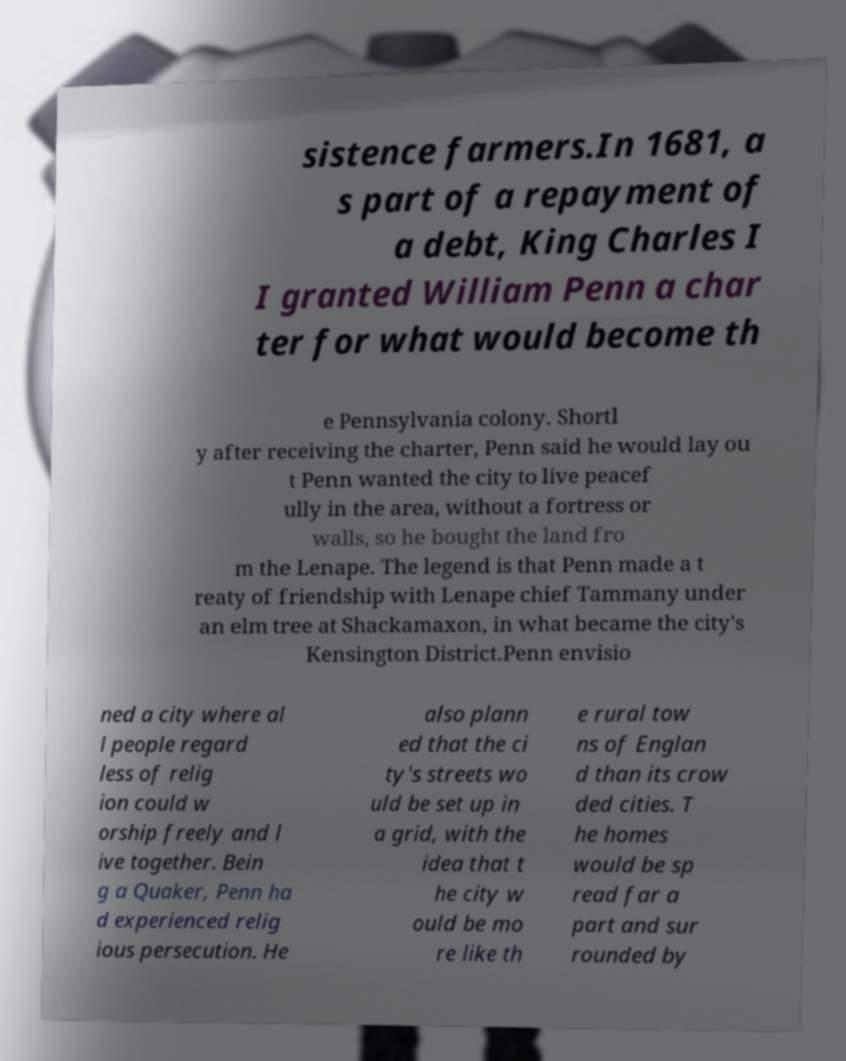I need the written content from this picture converted into text. Can you do that? sistence farmers.In 1681, a s part of a repayment of a debt, King Charles I I granted William Penn a char ter for what would become th e Pennsylvania colony. Shortl y after receiving the charter, Penn said he would lay ou t Penn wanted the city to live peacef ully in the area, without a fortress or walls, so he bought the land fro m the Lenape. The legend is that Penn made a t reaty of friendship with Lenape chief Tammany under an elm tree at Shackamaxon, in what became the city's Kensington District.Penn envisio ned a city where al l people regard less of relig ion could w orship freely and l ive together. Bein g a Quaker, Penn ha d experienced relig ious persecution. He also plann ed that the ci ty's streets wo uld be set up in a grid, with the idea that t he city w ould be mo re like th e rural tow ns of Englan d than its crow ded cities. T he homes would be sp read far a part and sur rounded by 